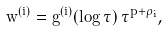Convert formula to latex. <formula><loc_0><loc_0><loc_500><loc_500>w ^ { ( i ) } = g ^ { ( i ) } ( \log \tau ) \, \tau ^ { p + \rho _ { i } } ,</formula> 